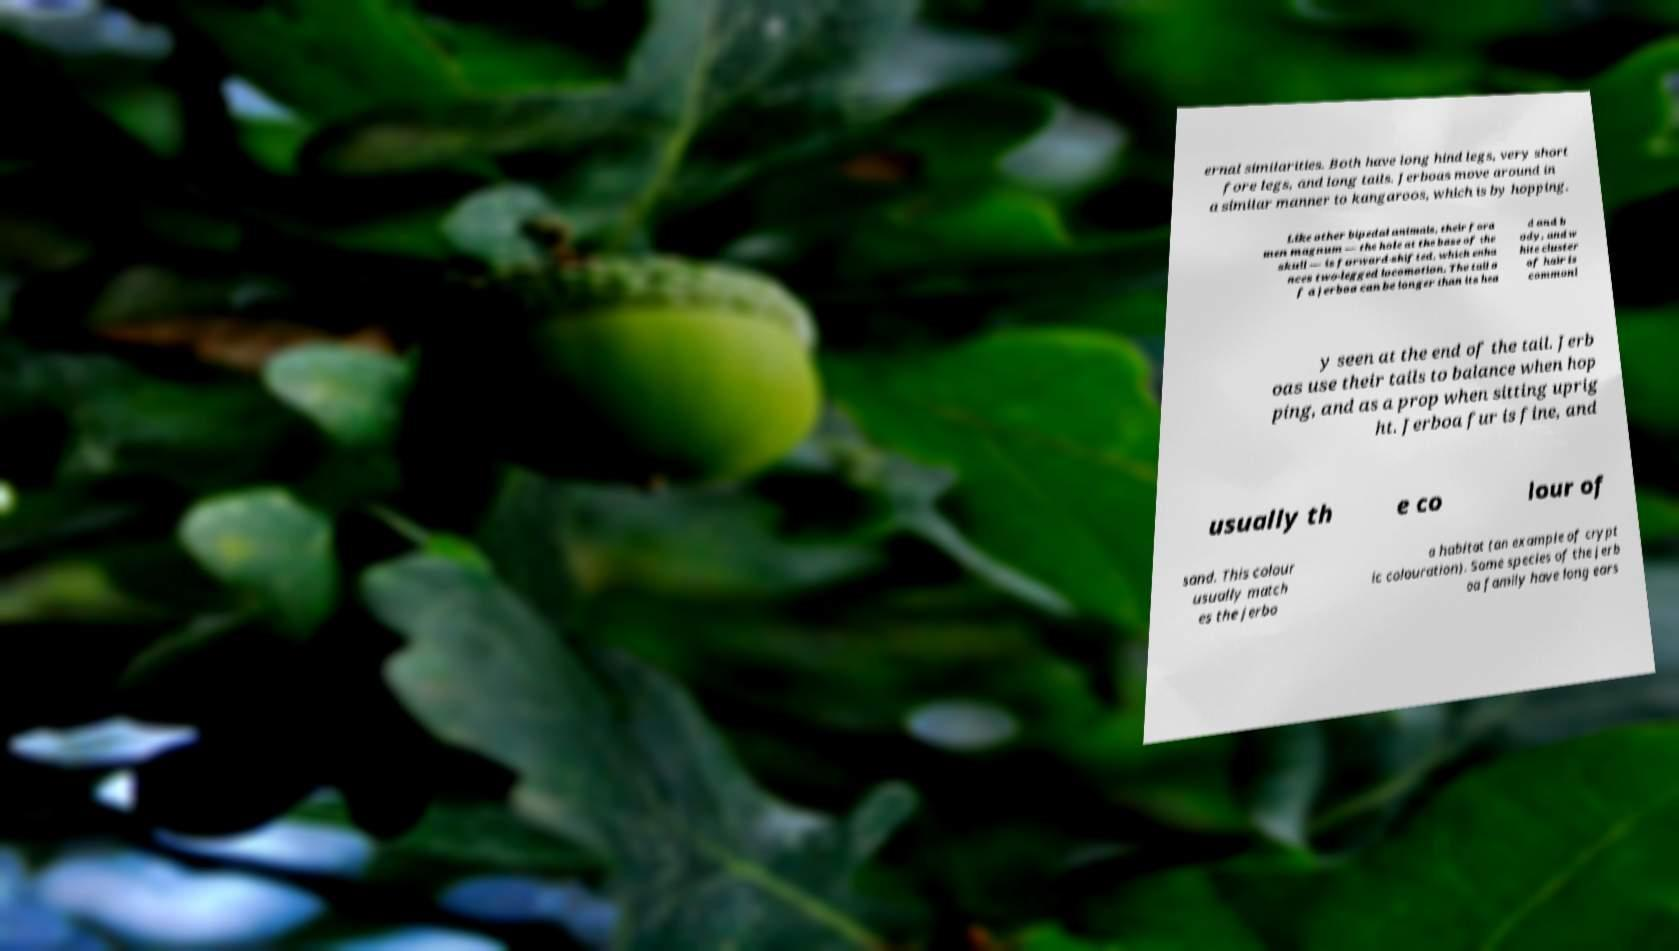Can you accurately transcribe the text from the provided image for me? ernal similarities. Both have long hind legs, very short fore legs, and long tails. Jerboas move around in a similar manner to kangaroos, which is by hopping. Like other bipedal animals, their fora men magnum — the hole at the base of the skull — is forward-shifted, which enha nces two-legged locomotion. The tail o f a jerboa can be longer than its hea d and b ody, and w hite cluster of hair is commonl y seen at the end of the tail. Jerb oas use their tails to balance when hop ping, and as a prop when sitting uprig ht. Jerboa fur is fine, and usually th e co lour of sand. This colour usually match es the jerbo a habitat (an example of crypt ic colouration). Some species of the jerb oa family have long ears 